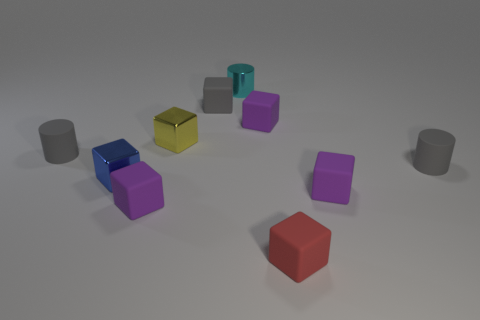The small yellow thing has what shape? The small yellow object in the image is shaped like a cube with equal sides, giving it a symmetrical and three-dimensional square geometry. 